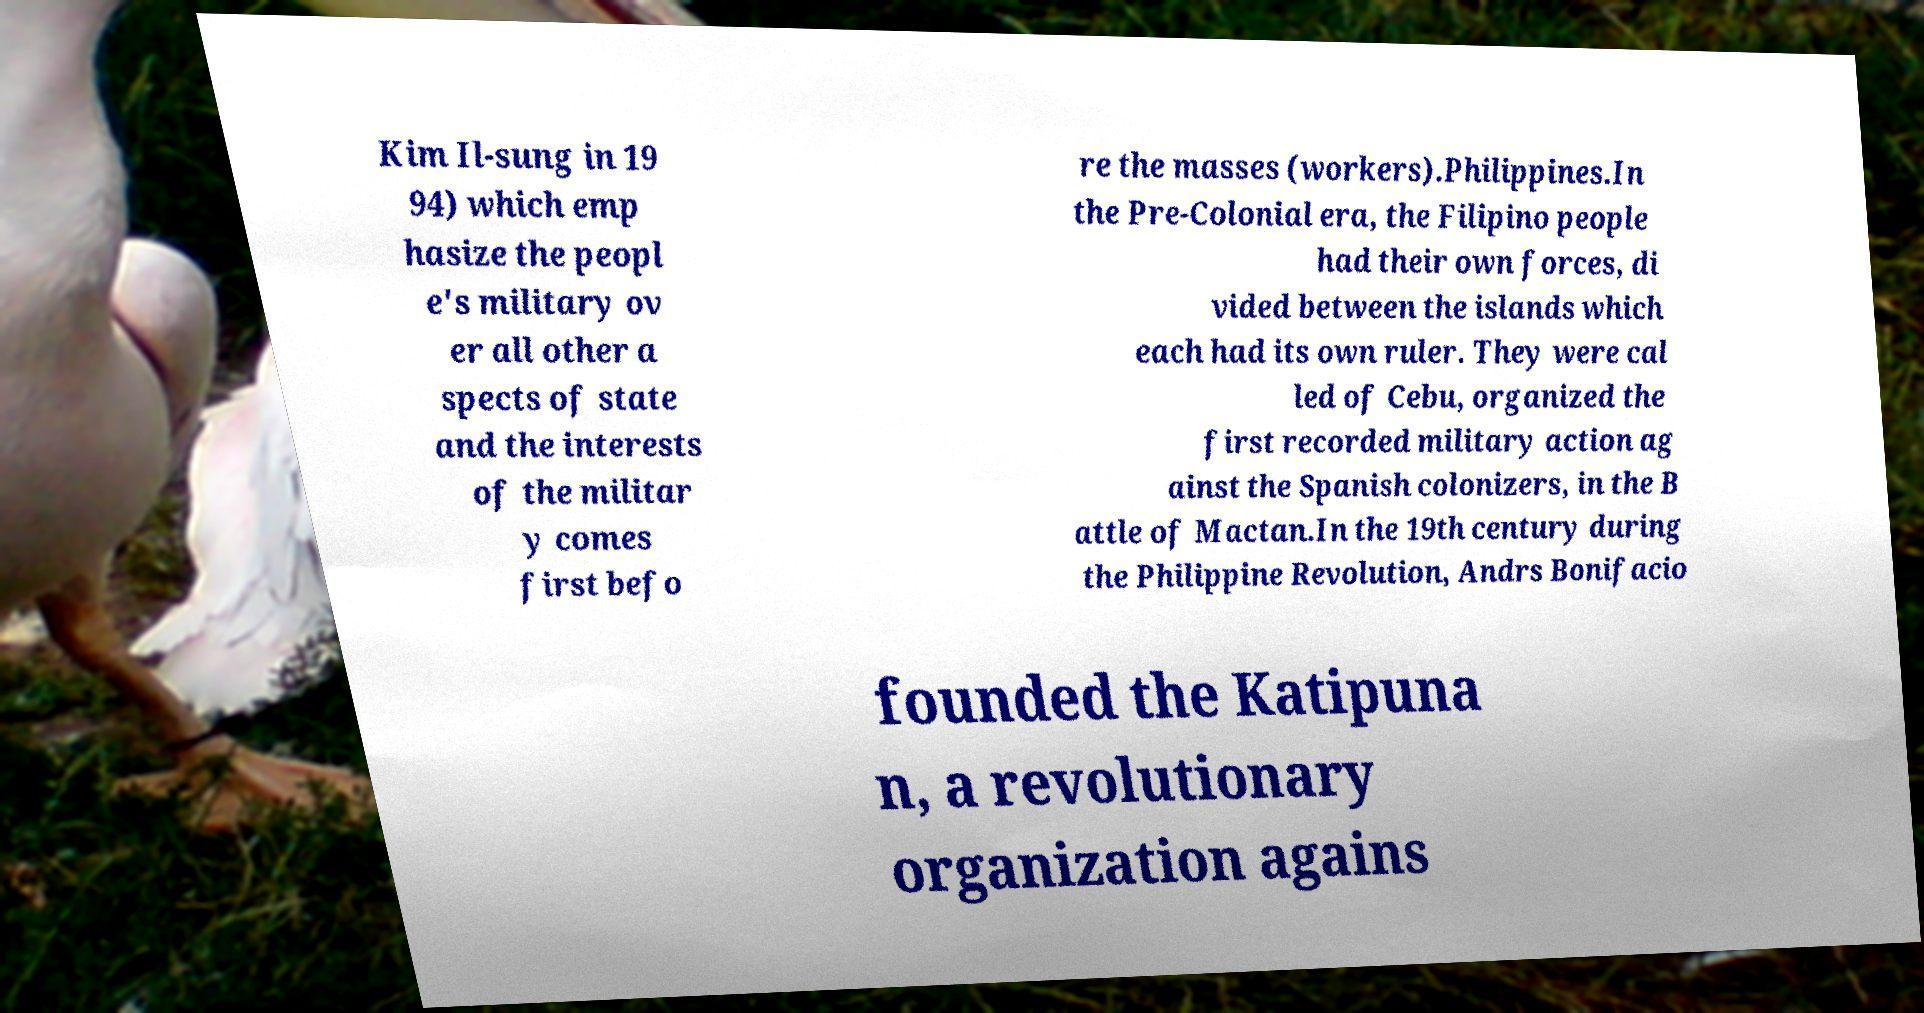Please read and relay the text visible in this image. What does it say? Kim Il-sung in 19 94) which emp hasize the peopl e's military ov er all other a spects of state and the interests of the militar y comes first befo re the masses (workers).Philippines.In the Pre-Colonial era, the Filipino people had their own forces, di vided between the islands which each had its own ruler. They were cal led of Cebu, organized the first recorded military action ag ainst the Spanish colonizers, in the B attle of Mactan.In the 19th century during the Philippine Revolution, Andrs Bonifacio founded the Katipuna n, a revolutionary organization agains 